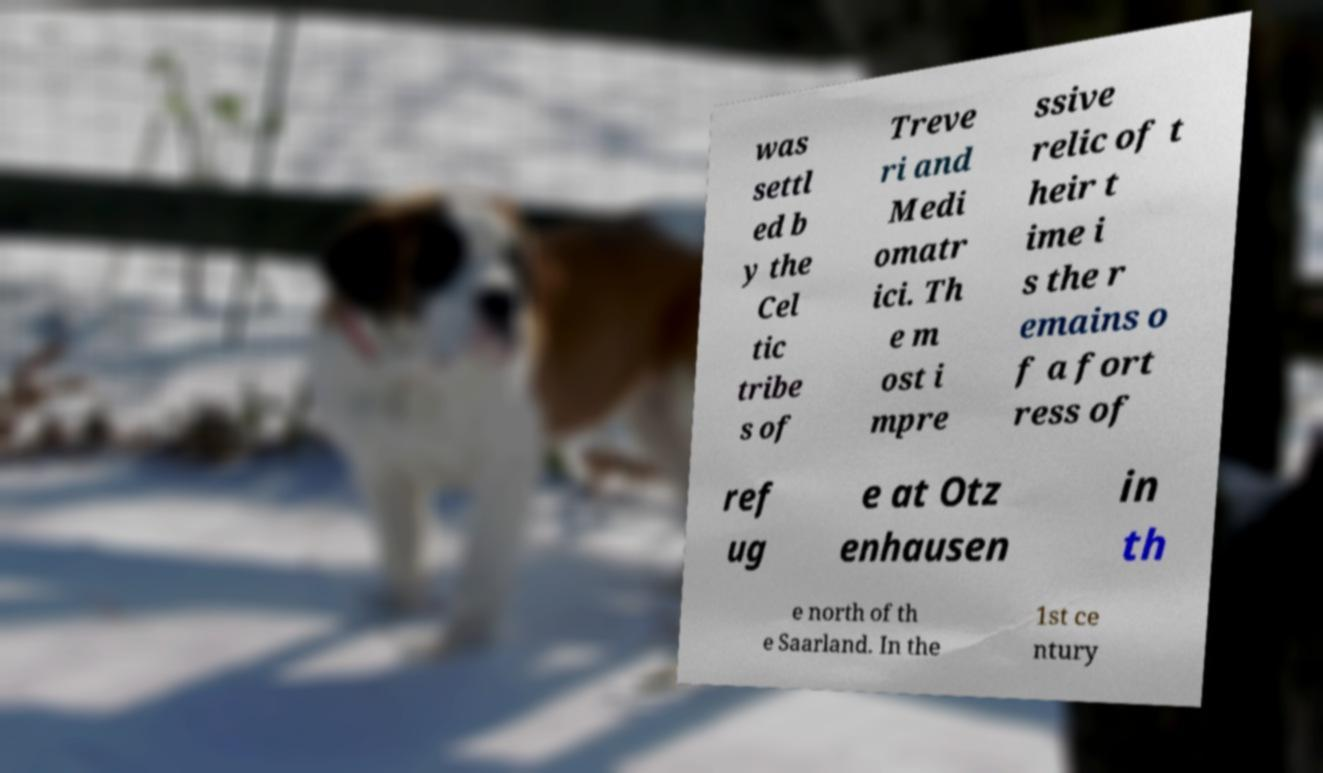For documentation purposes, I need the text within this image transcribed. Could you provide that? was settl ed b y the Cel tic tribe s of Treve ri and Medi omatr ici. Th e m ost i mpre ssive relic of t heir t ime i s the r emains o f a fort ress of ref ug e at Otz enhausen in th e north of th e Saarland. In the 1st ce ntury 